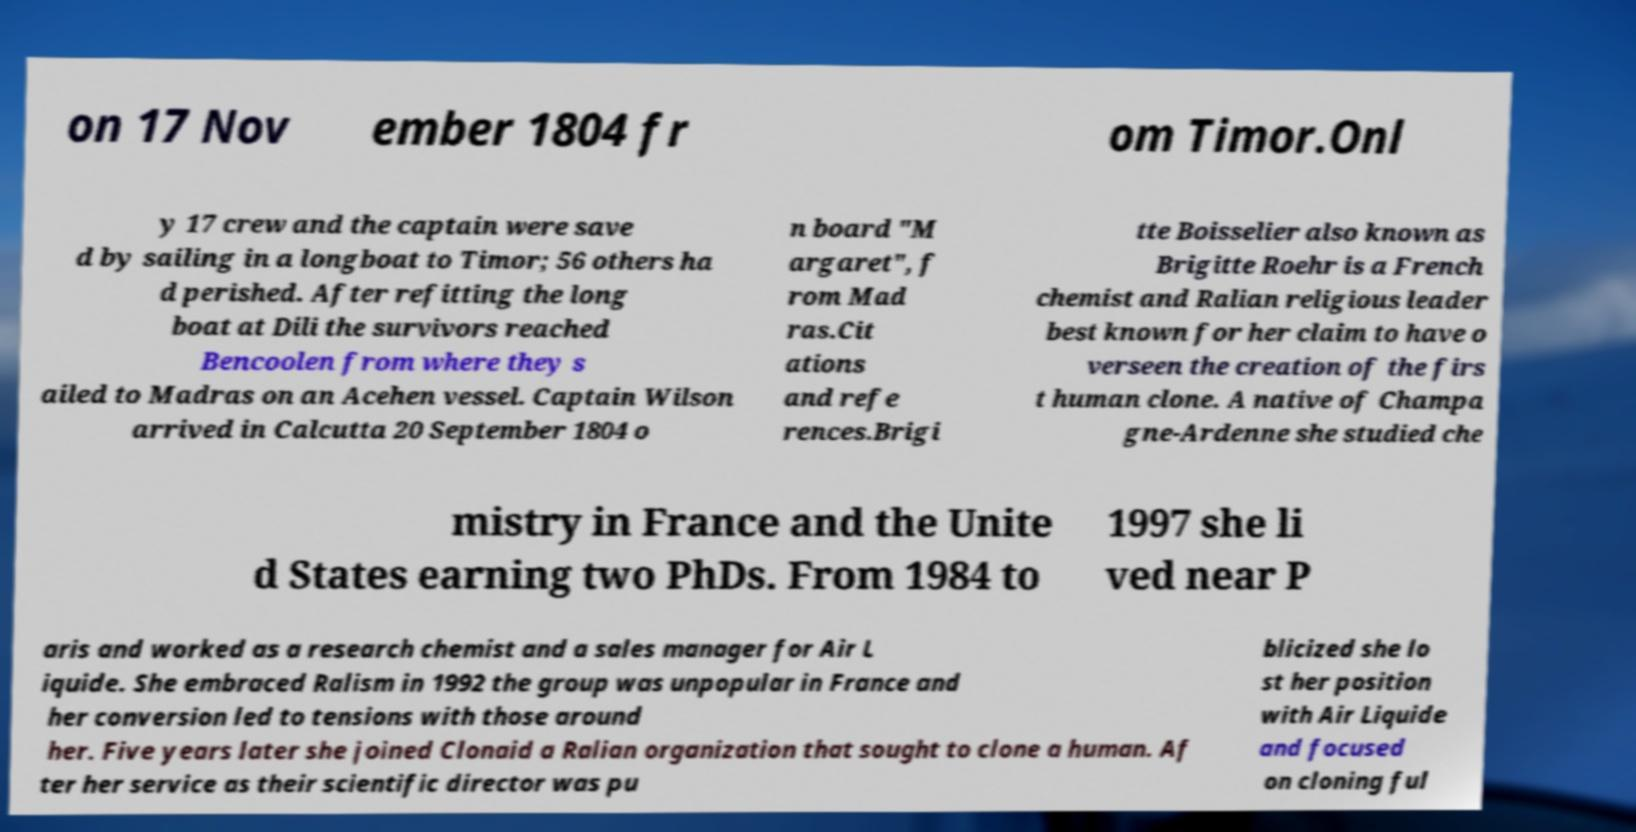There's text embedded in this image that I need extracted. Can you transcribe it verbatim? on 17 Nov ember 1804 fr om Timor.Onl y 17 crew and the captain were save d by sailing in a longboat to Timor; 56 others ha d perished. After refitting the long boat at Dili the survivors reached Bencoolen from where they s ailed to Madras on an Acehen vessel. Captain Wilson arrived in Calcutta 20 September 1804 o n board "M argaret", f rom Mad ras.Cit ations and refe rences.Brigi tte Boisselier also known as Brigitte Roehr is a French chemist and Ralian religious leader best known for her claim to have o verseen the creation of the firs t human clone. A native of Champa gne-Ardenne she studied che mistry in France and the Unite d States earning two PhDs. From 1984 to 1997 she li ved near P aris and worked as a research chemist and a sales manager for Air L iquide. She embraced Ralism in 1992 the group was unpopular in France and her conversion led to tensions with those around her. Five years later she joined Clonaid a Ralian organization that sought to clone a human. Af ter her service as their scientific director was pu blicized she lo st her position with Air Liquide and focused on cloning ful 